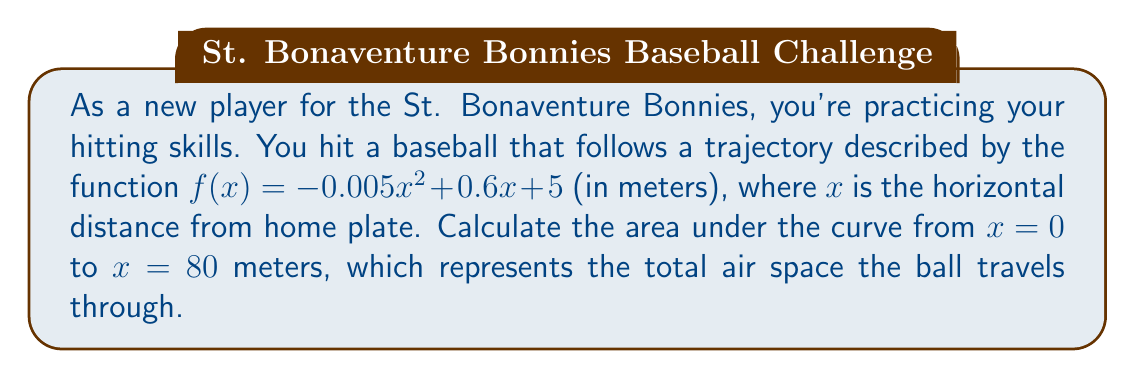Solve this math problem. To find the area under the curve, we need to integrate the function $f(x)$ from $x = 0$ to $x = 80$. Here's how we do it step by step:

1) The integral we need to calculate is:
   $$\int_0^{80} (-0.005x^2 + 0.6x + 5) dx$$

2) Let's integrate each term separately:
   
   For $-0.005x^2$: $$\int -0.005x^2 dx = -0.005 \cdot \frac{x^3}{3} + C$$
   
   For $0.6x$: $$\int 0.6x dx = 0.3x^2 + C$$
   
   For $5$: $$\int 5 dx = 5x + C$$

3) Combining these, we get:
   $$\int (-0.005x^2 + 0.6x + 5) dx = -\frac{0.005x^3}{3} + 0.3x^2 + 5x + C$$

4) Now, we need to evaluate this from 0 to 80:
   
   $$[-\frac{0.005x^3}{3} + 0.3x^2 + 5x]_0^{80}$$

5) Let's calculate for $x = 80$ and $x = 0$:
   
   For $x = 80$: $$-\frac{0.005(80^3)}{3} + 0.3(80^2) + 5(80) = -2133.33 + 1920 + 400 = 186.67$$
   
   For $x = 0$: $$-\frac{0.005(0^3)}{3} + 0.3(0^2) + 5(0) = 0$$

6) The area is the difference between these values:
   $$186.67 - 0 = 186.67$$

Therefore, the area under the curve is approximately 186.67 square meters.
Answer: 186.67 square meters 